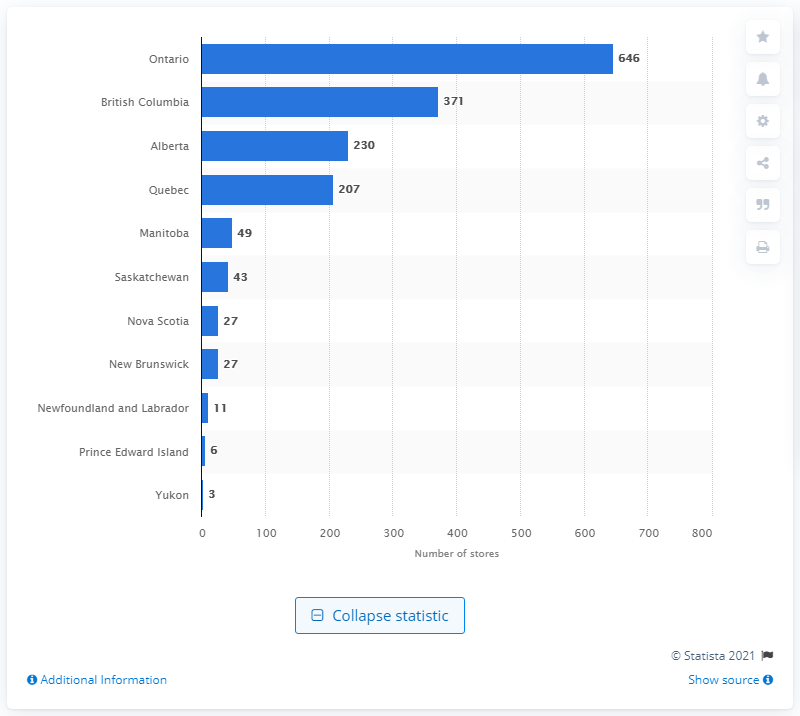Specify some key components in this picture. As of December 2020, there were 646 food health supplement stores in Ontario. As of December 2020, there were 371 food health supplement stores operating in British Columbia. 